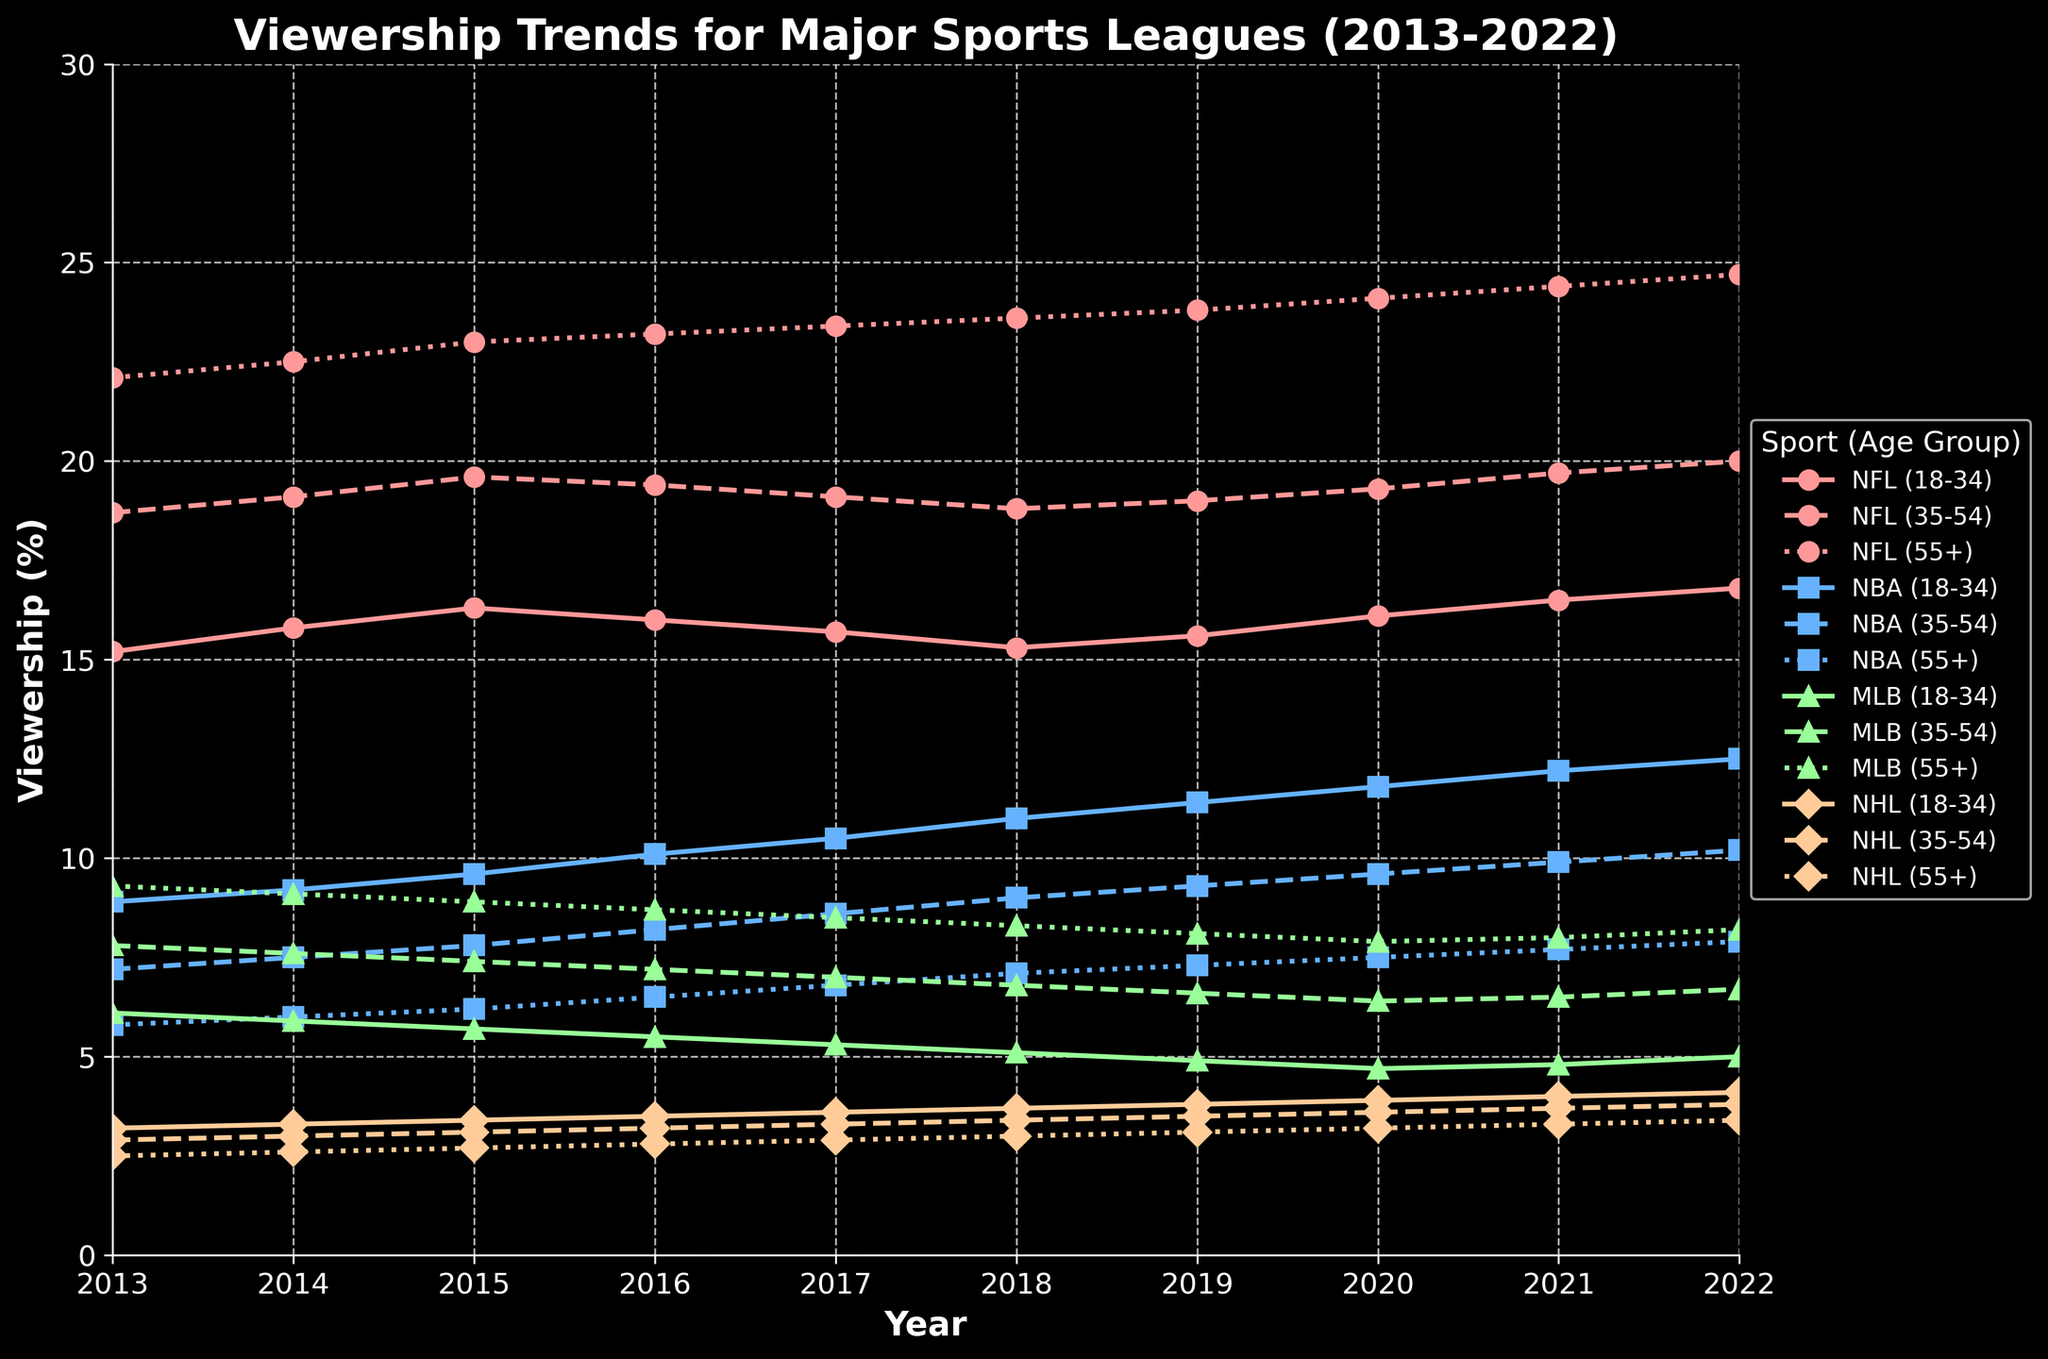Which sport saw the highest viewership in the 55+ age group in 2018? To determine this, examine the lines for each sport labeled (55+) in 2018. The NFL (55+) is highest at 23.6.
Answer: NFL How did the viewership trend for NBA (18-34) change from 2013 to 2022? Look at the line representing NBA (18-34) across the years from 2013 to 2022. It shows a steady increase from 8.9 in 2013 to 12.5 in 2022.
Answer: Increased Which age group showed the smallest viewership growth for MLB over the decade? Compare the growth in viewership from 2013 to 2022 among the three age groups for MLB. MLB (18-34) grew from 6.1 to 5.0, which is a decrease, the smallest growth.
Answer: 18-34 What is the average viewership for NFL (35-54) over the decade? Calculate the average viewership from 2013 to 2022 for NFL (35-54). The sum of values is 18.7+19.1+19.6+19.4+19.1+18.8+19.0+19.3+19.7+20.0 = 193.7 and the average is 193.7/10 = 19.37.
Answer: 19.37 Comparing NBA and NHL, which one had more growth in the viewership for the 18-34 age group over the decade? Calculate the difference in viewership from 2013 to 2022 for both NBA and NHL in the 18-34 age group. NBA (18-34) grew from 8.9 to 12.5 (3.6) while NHL grew from 3.2 to 4.1 (0.9). NBA had more growth.
Answer: NBA In which year did NFL viewership for the 55+ age group start surpassing 24%? Find the first year NFL (55+) line crosses 24% on the y-axis. In 2020, it reaches 24.1%.
Answer: 2020 Which sports age group's viewership saw the most decline from 2013 to 2020? Calculate the changes from 2013 to 2020 for all sports and age groups. MLB (18-34) declined from 6.1 to 4.7, showing the steepest decline of 1.4.
Answer: MLB (18-34) What is the combined viewership percentage of NBA (35-54) and MLB (35-54) in 2022? Add the viewership percentages of NBA (35-54) and MLB (35-54) for the year 2022. NBA is 10.2 and MLB is 6.7, totalling 10.2 + 6.7 = 16.9.
Answer: 16.9 Which age group has the least difference in viewership between NFL and NBA in 2022? For 2022, calculate the differences between NFL and NBA viewership in each age group: (18-34) is 16.8 - 12.5 = 4.3, (35-54) is 20.0 - 10.2 = 9.8, (55+) is 24.7 - 7.9 = 16.8. The least difference is in the 18-34 age group.
Answer: 18-34 How does the slope of the NHL (18-34) trend compare visually to the slope of NBA (18-34) over the decade? Visually compare the steepness of the lines for NHL (18-34) and NBA (18-34). NHL's line is less steep compared to NBA's upward trend, indicating a slower increase.
Answer: NHL has a gentler slope 